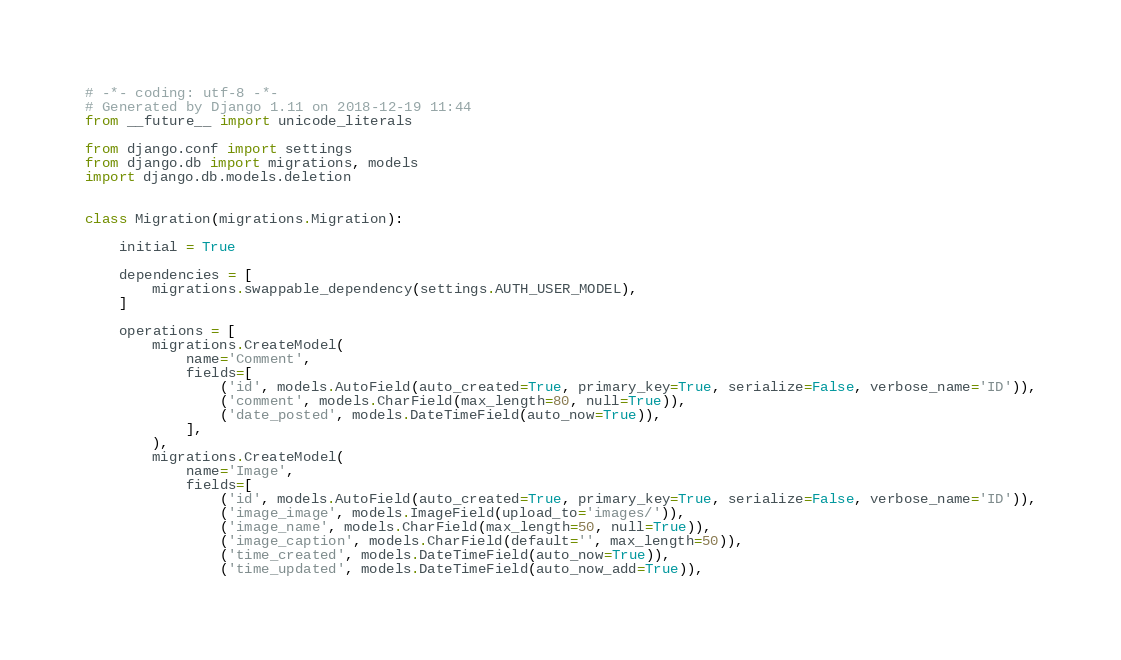Convert code to text. <code><loc_0><loc_0><loc_500><loc_500><_Python_># -*- coding: utf-8 -*-
# Generated by Django 1.11 on 2018-12-19 11:44
from __future__ import unicode_literals

from django.conf import settings
from django.db import migrations, models
import django.db.models.deletion


class Migration(migrations.Migration):

    initial = True

    dependencies = [
        migrations.swappable_dependency(settings.AUTH_USER_MODEL),
    ]

    operations = [
        migrations.CreateModel(
            name='Comment',
            fields=[
                ('id', models.AutoField(auto_created=True, primary_key=True, serialize=False, verbose_name='ID')),
                ('comment', models.CharField(max_length=80, null=True)),
                ('date_posted', models.DateTimeField(auto_now=True)),
            ],
        ),
        migrations.CreateModel(
            name='Image',
            fields=[
                ('id', models.AutoField(auto_created=True, primary_key=True, serialize=False, verbose_name='ID')),
                ('image_image', models.ImageField(upload_to='images/')),
                ('image_name', models.CharField(max_length=50, null=True)),
                ('image_caption', models.CharField(default='', max_length=50)),
                ('time_created', models.DateTimeField(auto_now=True)),
                ('time_updated', models.DateTimeField(auto_now_add=True)),</code> 